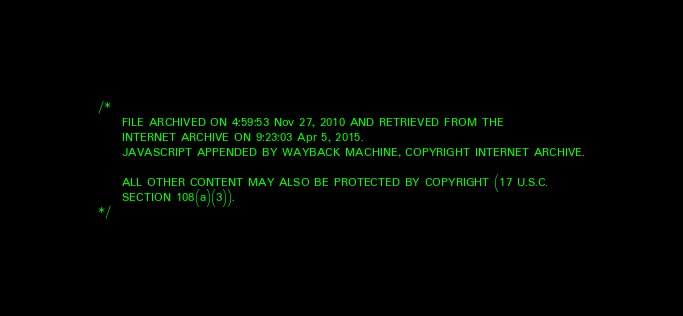<code> <loc_0><loc_0><loc_500><loc_500><_JavaScript_>




/*
     FILE ARCHIVED ON 4:59:53 Nov 27, 2010 AND RETRIEVED FROM THE
     INTERNET ARCHIVE ON 9:23:03 Apr 5, 2015.
     JAVASCRIPT APPENDED BY WAYBACK MACHINE, COPYRIGHT INTERNET ARCHIVE.

     ALL OTHER CONTENT MAY ALSO BE PROTECTED BY COPYRIGHT (17 U.S.C.
     SECTION 108(a)(3)).
*/</code> 